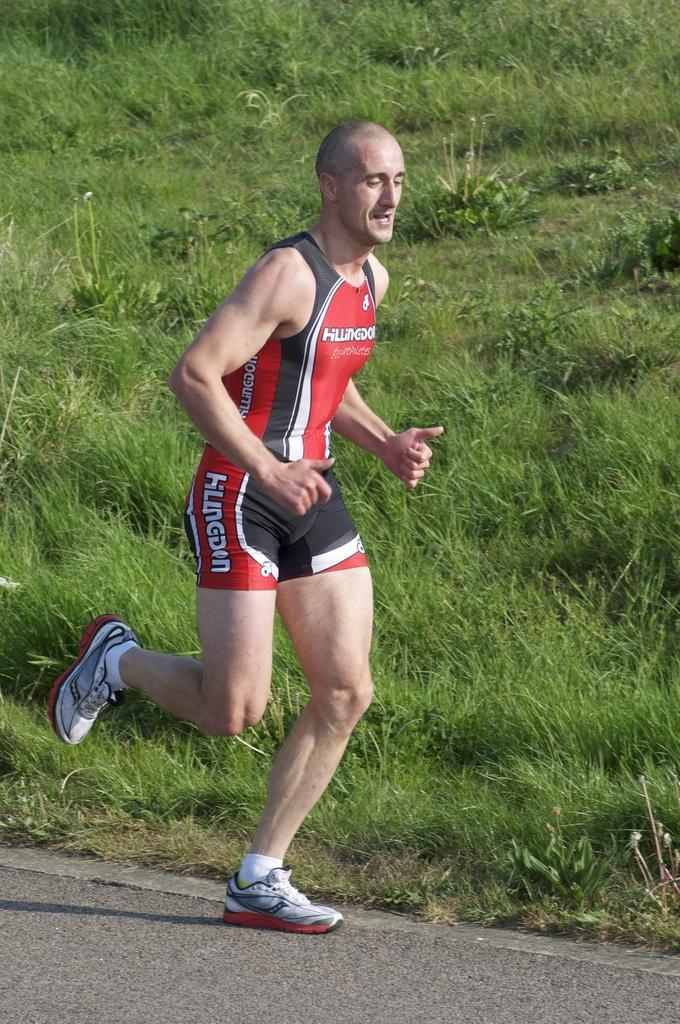<image>
Create a compact narrative representing the image presented. Gentleman in a Hillingdon running outfit running next to a grassy hill. 